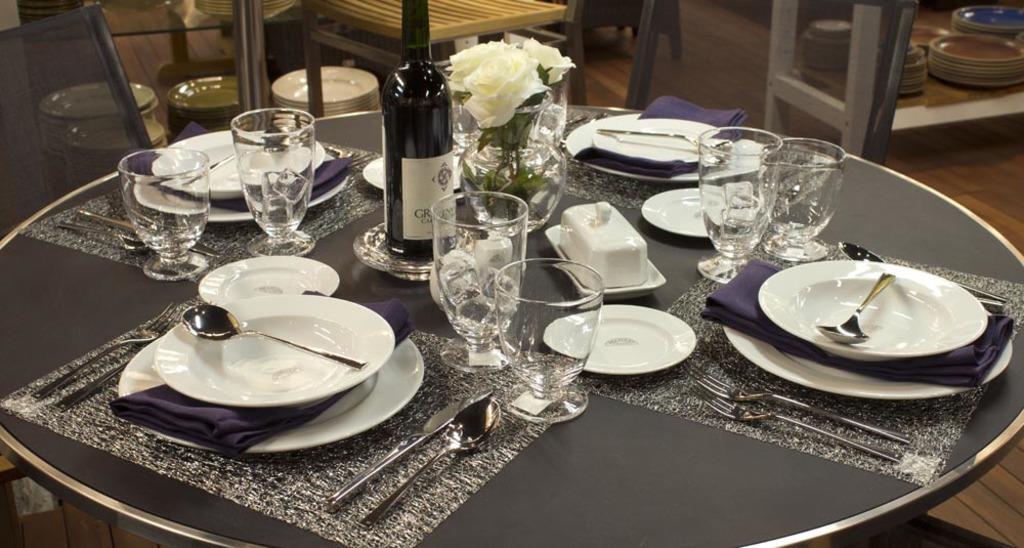Please provide a concise description of this image. There are plates,spoons,forks,glasses,cloth,flower vase and a wine bottle on the table. In the background there are chairs and plates. 